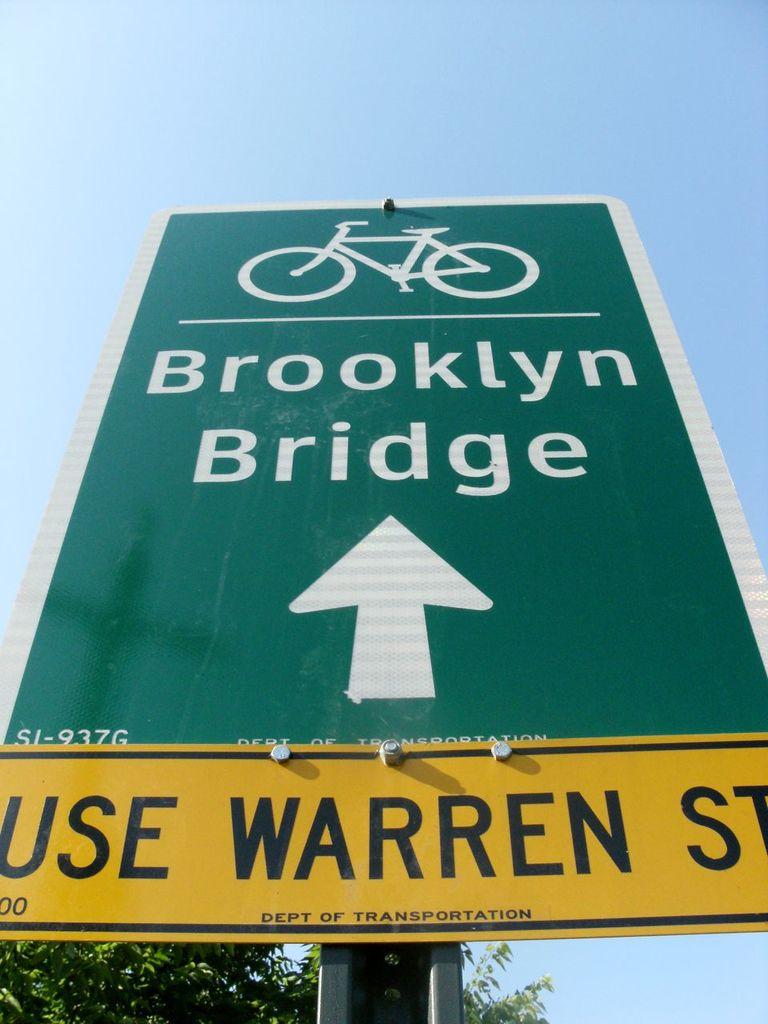What street does the yellow sign say to use?
Keep it short and to the point. Warren st. 